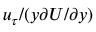Convert formula to latex. <formula><loc_0><loc_0><loc_500><loc_500>u _ { \tau } / ( y \partial U / \partial y )</formula> 